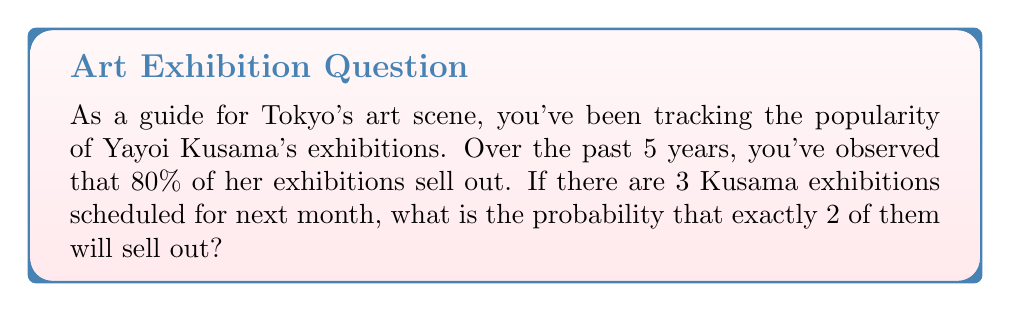Provide a solution to this math problem. To solve this problem, we'll use the Binomial probability distribution, as we have a fixed number of independent trials (exhibitions) with two possible outcomes (sell out or not) and a constant probability of success.

Let's define our variables:
$n = 3$ (number of exhibitions)
$k = 2$ (number of successful outcomes we're interested in)
$p = 0.8$ (probability of an exhibition selling out)
$q = 1 - p = 0.2$ (probability of an exhibition not selling out)

The probability mass function for the Binomial distribution is:

$$P(X = k) = \binom{n}{k} p^k q^{n-k}$$

Where $\binom{n}{k}$ is the binomial coefficient, calculated as:

$$\binom{n}{k} = \frac{n!}{k!(n-k)!}$$

Step 1: Calculate the binomial coefficient
$$\binom{3}{2} = \frac{3!}{2!(3-2)!} = \frac{3 \cdot 2 \cdot 1}{(2 \cdot 1)(1)} = 3$$

Step 2: Apply the probability mass function
$$P(X = 2) = 3 \cdot (0.8)^2 \cdot (0.2)^{3-2}$$
$$= 3 \cdot (0.8)^2 \cdot (0.2)^1$$
$$= 3 \cdot 0.64 \cdot 0.2$$
$$= 0.384$$

Therefore, the probability that exactly 2 out of 3 Kusama exhibitions will sell out is 0.384 or 38.4%.
Answer: 0.384 